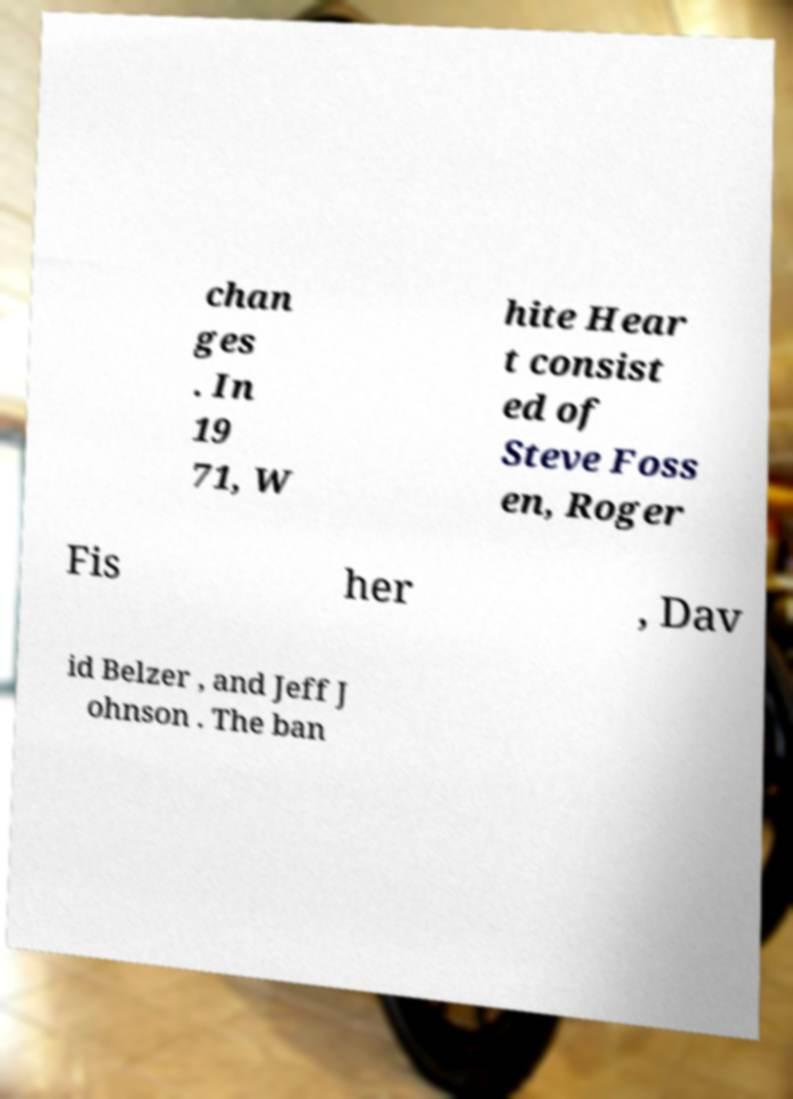Could you assist in decoding the text presented in this image and type it out clearly? chan ges . In 19 71, W hite Hear t consist ed of Steve Foss en, Roger Fis her , Dav id Belzer , and Jeff J ohnson . The ban 